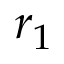<formula> <loc_0><loc_0><loc_500><loc_500>r _ { 1 }</formula> 